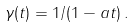<formula> <loc_0><loc_0><loc_500><loc_500>\gamma ( t ) = 1 / ( 1 - a t ) \, .</formula> 